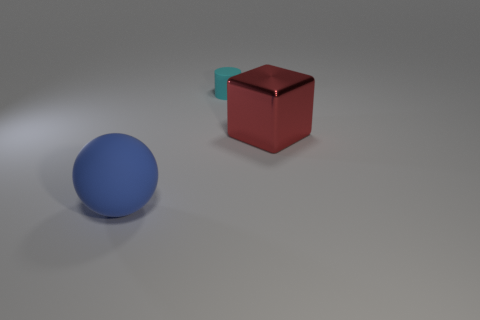There is a block in front of the matte object that is behind the large object left of the shiny object; what is its color?
Provide a succinct answer. Red. What number of cyan objects are the same shape as the big blue rubber thing?
Offer a very short reply. 0. There is a rubber thing behind the blue matte object that is on the left side of the cyan rubber thing; how big is it?
Ensure brevity in your answer.  Small. Do the cylinder and the blue ball have the same size?
Provide a short and direct response. No. There is a matte object that is in front of the thing behind the metal object; are there any tiny things in front of it?
Provide a short and direct response. No. How big is the cyan matte thing?
Your response must be concise. Small. What number of red blocks have the same size as the blue matte thing?
Make the answer very short. 1. There is a object that is on the left side of the big metallic thing and on the right side of the large blue rubber thing; what is its shape?
Provide a short and direct response. Cylinder. The big object that is on the left side of the small cyan thing has what shape?
Ensure brevity in your answer.  Sphere. What number of objects are both behind the large sphere and in front of the cyan matte object?
Make the answer very short. 1. 